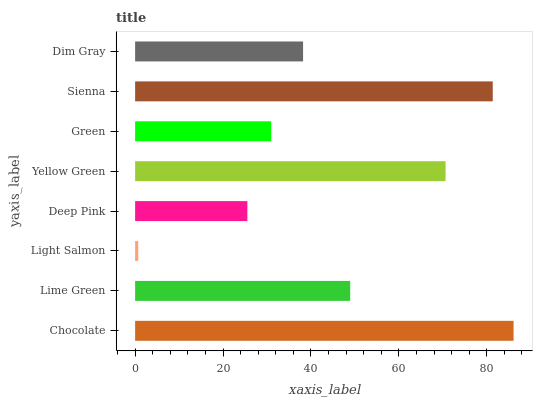Is Light Salmon the minimum?
Answer yes or no. Yes. Is Chocolate the maximum?
Answer yes or no. Yes. Is Lime Green the minimum?
Answer yes or no. No. Is Lime Green the maximum?
Answer yes or no. No. Is Chocolate greater than Lime Green?
Answer yes or no. Yes. Is Lime Green less than Chocolate?
Answer yes or no. Yes. Is Lime Green greater than Chocolate?
Answer yes or no. No. Is Chocolate less than Lime Green?
Answer yes or no. No. Is Lime Green the high median?
Answer yes or no. Yes. Is Dim Gray the low median?
Answer yes or no. Yes. Is Green the high median?
Answer yes or no. No. Is Light Salmon the low median?
Answer yes or no. No. 